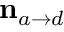Convert formula to latex. <formula><loc_0><loc_0><loc_500><loc_500>{ n } _ { a \to d }</formula> 